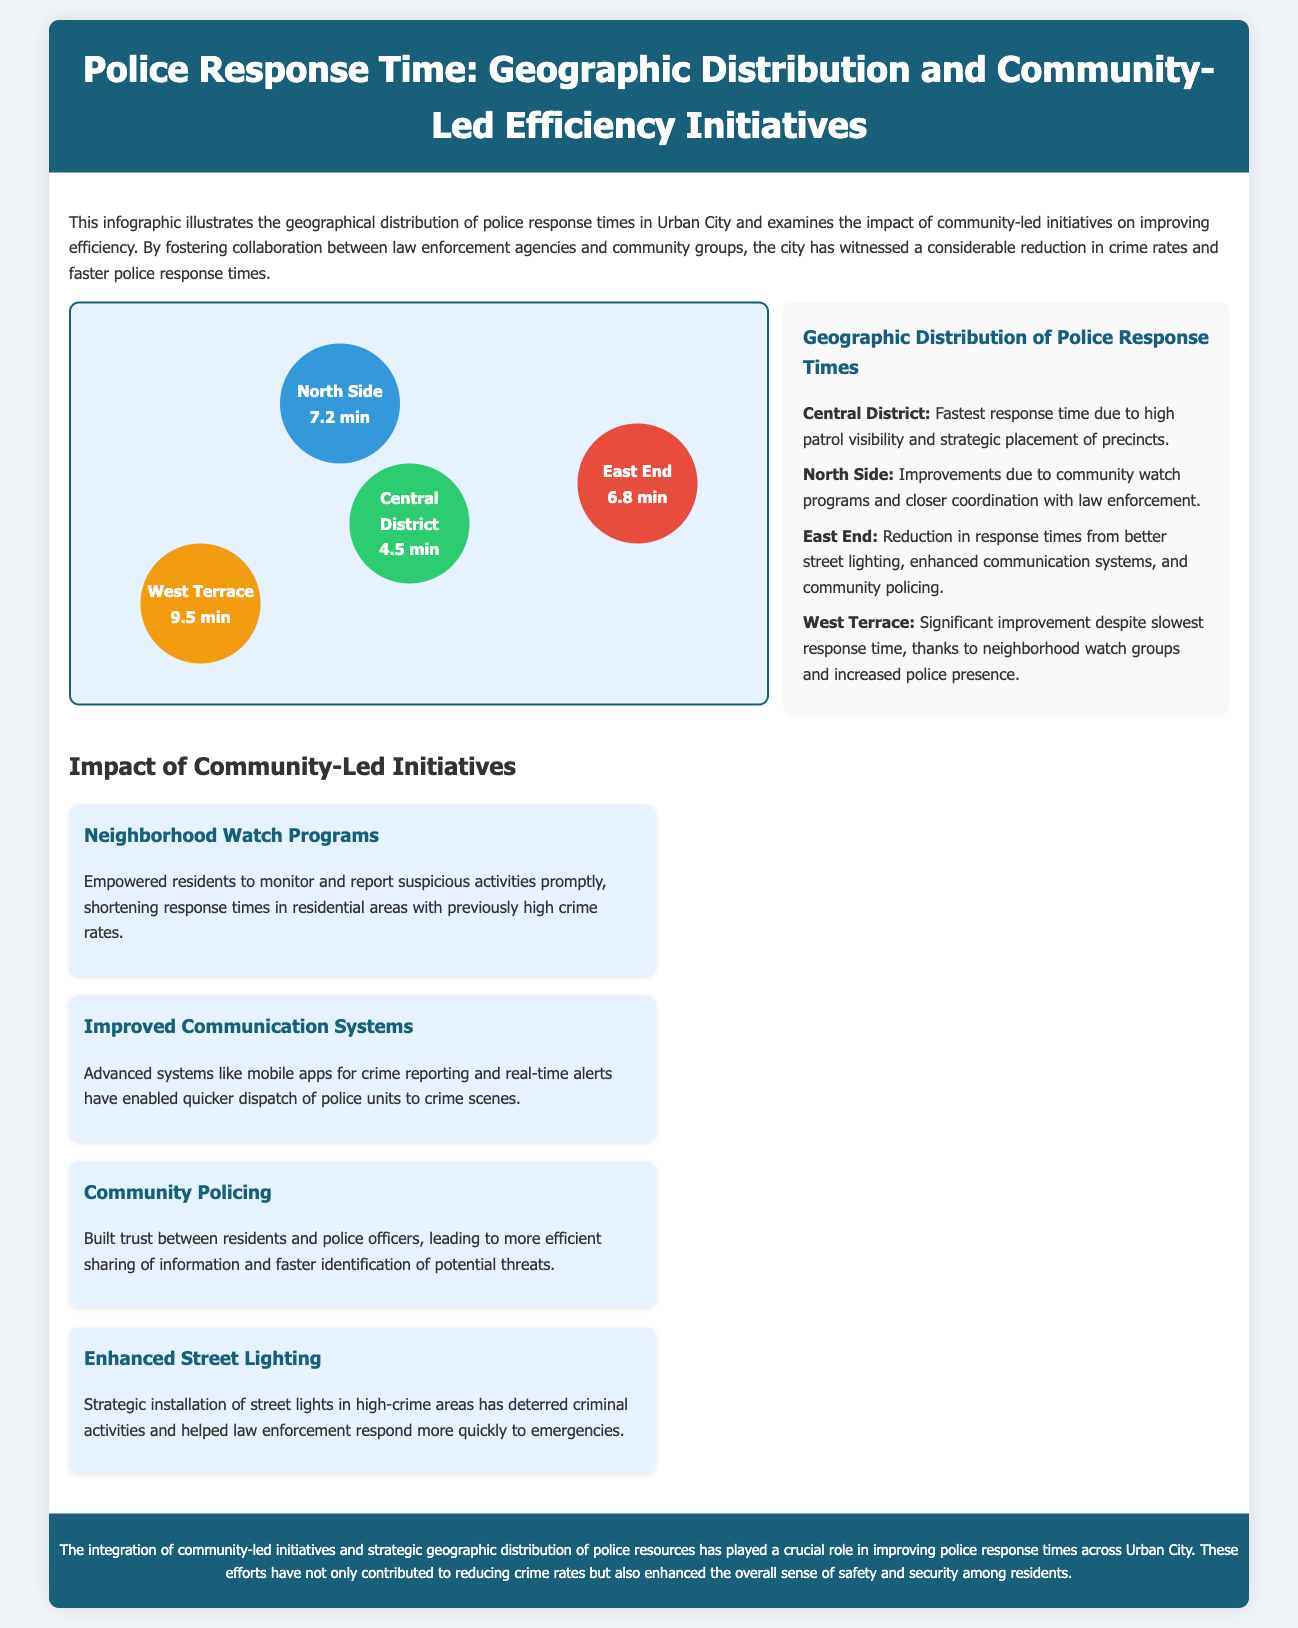What is the fastest response time? The fastest response time is given for the Central District, which is 4.5 minutes.
Answer: 4.5 min Which district has the slowest response time? The slowest response time is noted for the West Terrace, which is 9.5 minutes.
Answer: 9.5 min What initiative improved communication systems? The initiative focused on advanced systems like mobile apps for crime reporting and real-time alerts.
Answer: Improved Communication Systems What are the two main factors contributing to the North Side's response time improvement? The North Side's improvement is linked to community watch programs and closer coordination with law enforcement.
Answer: Community watch programs and closer coordination What is one impact of enhanced street lighting mentioned? Enhancement in street lighting strategically installed in high-crime areas has deterred criminal activities and helped law enforcement.
Answer: Deterred criminal activities How has community policing affected residents' trust? Community policing has built trust between residents and police officers, improving information sharing.
Answer: Built trust What is the color representing the Central District on the map? The Central District is colored green, indicated by its background color.
Answer: Green Which area has a response time reduction due to better street lighting? The East End has reduced response times due to better street lighting.
Answer: East End What geographical aspect does the infographic focus on? The infographic focuses on the geographic distribution of police response times.
Answer: Geographic distribution 